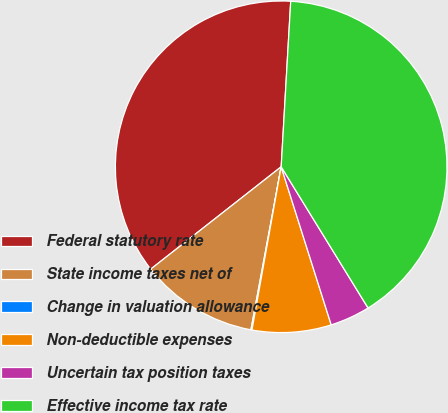Convert chart to OTSL. <chart><loc_0><loc_0><loc_500><loc_500><pie_chart><fcel>Federal statutory rate<fcel>State income taxes net of<fcel>Change in valuation allowance<fcel>Non-deductible expenses<fcel>Uncertain tax position taxes<fcel>Effective income tax rate<nl><fcel>36.5%<fcel>11.49%<fcel>0.1%<fcel>7.7%<fcel>3.9%<fcel>40.3%<nl></chart> 